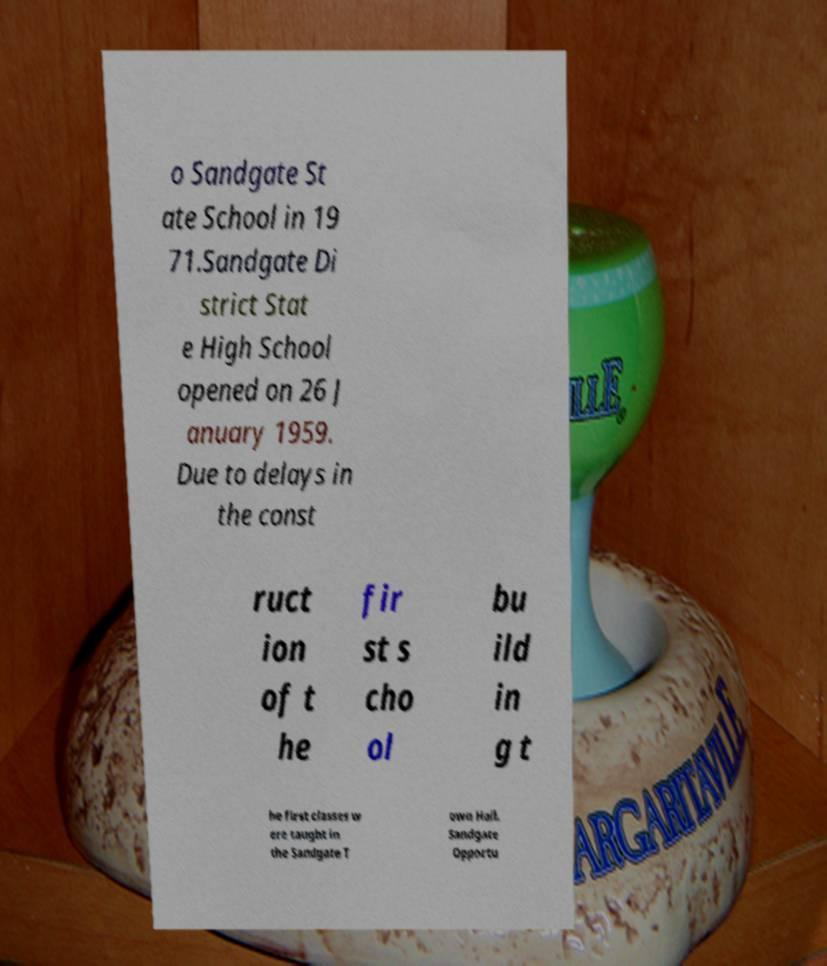Can you accurately transcribe the text from the provided image for me? o Sandgate St ate School in 19 71.Sandgate Di strict Stat e High School opened on 26 J anuary 1959. Due to delays in the const ruct ion of t he fir st s cho ol bu ild in g t he first classes w ere taught in the Sandgate T own Hall. Sandgate Opportu 